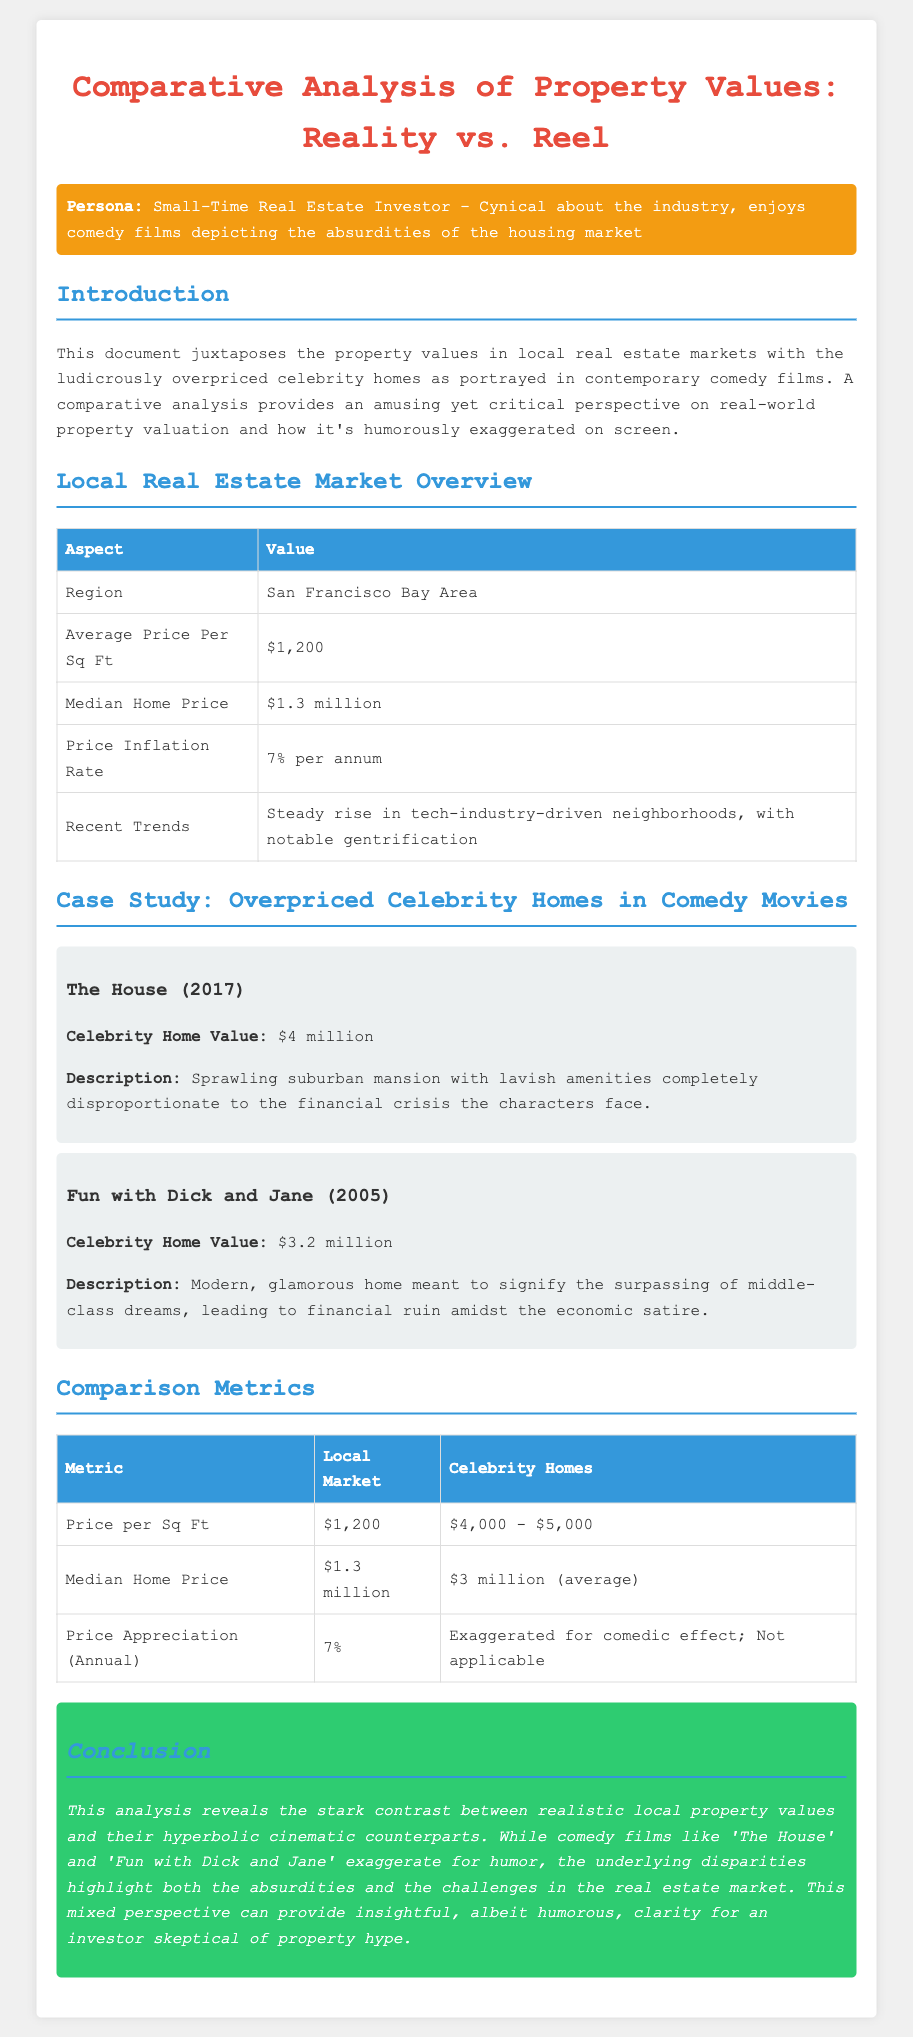what is the average price per square foot in the local market? The average price per square foot in the local market is listed in a table in the document.
Answer: $1,200 what is the median home price in the San Francisco Bay Area? The median home price can be found in the Local Real Estate Market Overview section of the document.
Answer: $1.3 million what is the price inflation rate mentioned? The price inflation rate provides insight into market trends, stated in the overview.
Answer: 7% per annum how much is the celebrity home value in "The House"? The celebrity home value can be extracted from the case study of 'The House' in the document.
Answer: $4 million what is the price per square foot for celebrity homes? The price per square foot for celebrity homes is detailed in the Comparison Metrics table in the document.
Answer: $4,000 - $5,000 what is the average celebrity home price mentioned? The average celebrity home price is highlighted in the comparison metrics section.
Answer: $3 million which movie features a home valued at $3.2 million? The title of the movie is found within the case study descriptions in the document.
Answer: Fun with Dick and Jane what is noted about recent trends in the local market? Recent trends are summarized in a single phrase in the Local Real Estate Market Overview table.
Answer: Steady rise in tech-industry-driven neighborhoods, with notable gentrification what do the comedy films exaggerate for? The analysis addresses the purpose of exaggeration within the films.
Answer: Humor 